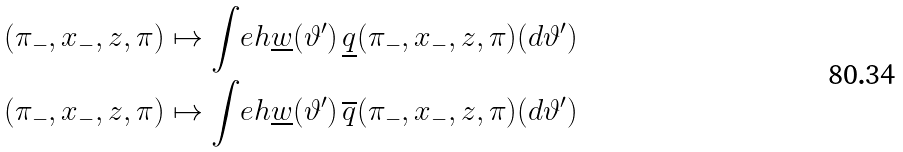<formula> <loc_0><loc_0><loc_500><loc_500>& ( \pi _ { - } , x _ { - } , z , \pi ) \mapsto \int _ { \ } e h \underline { w } ( \vartheta ^ { \prime } ) \, \underline { q } ( \pi _ { - } , x _ { - } , z , \pi ) ( d \vartheta ^ { \prime } ) \\ & ( \pi _ { - } , x _ { - } , z , \pi ) \mapsto \int _ { \ } e h \underline { w } ( \vartheta ^ { \prime } ) \, \overline { q } ( \pi _ { - } , x _ { - } , z , \pi ) ( d \vartheta ^ { \prime } )</formula> 